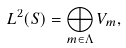<formula> <loc_0><loc_0><loc_500><loc_500>L ^ { 2 } ( S ) = \bigoplus _ { m \in \Lambda } V _ { m } ,</formula> 